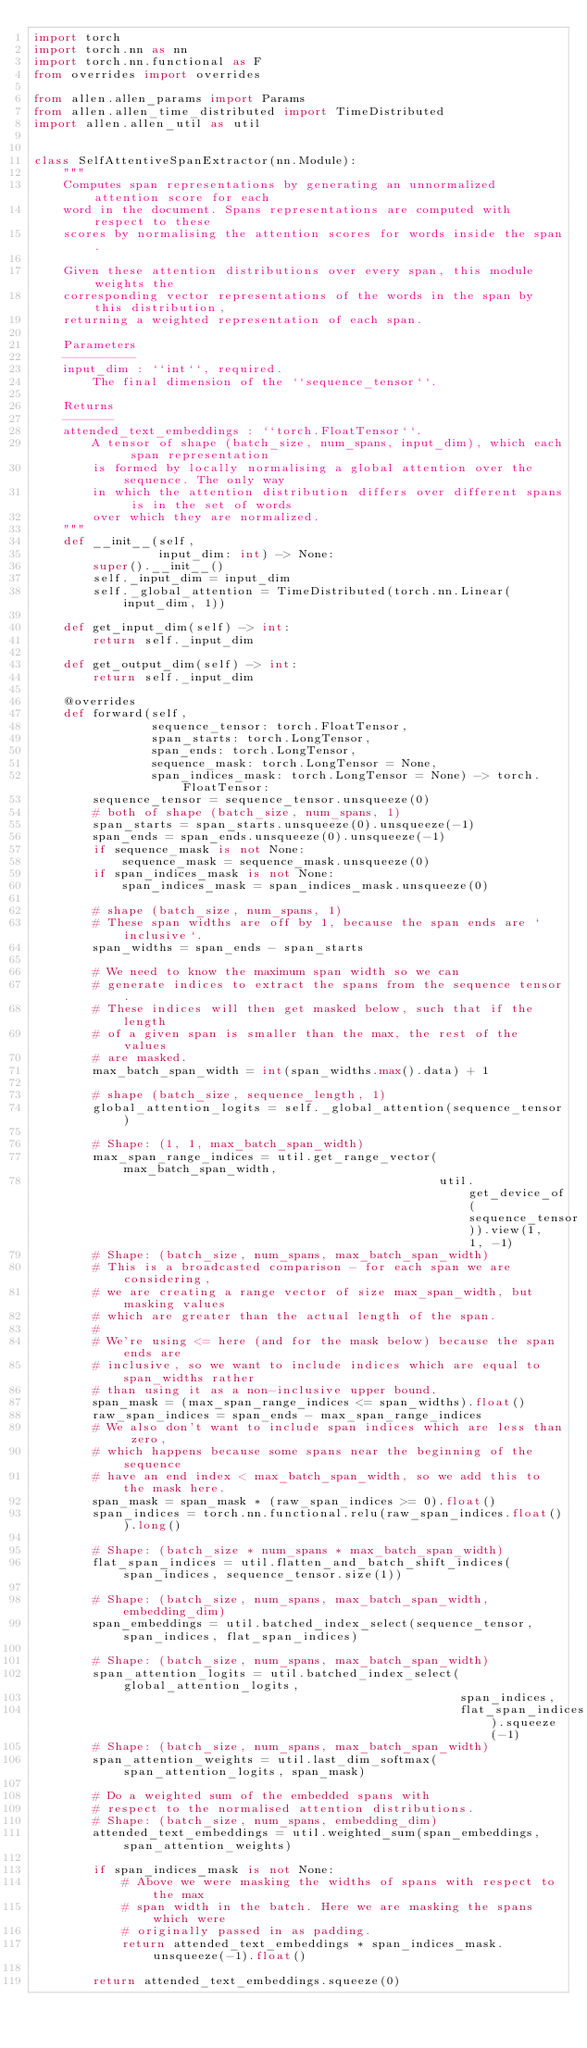Convert code to text. <code><loc_0><loc_0><loc_500><loc_500><_Python_>import torch
import torch.nn as nn
import torch.nn.functional as F
from overrides import overrides

from allen.allen_params import Params
from allen.allen_time_distributed import TimeDistributed
import allen.allen_util as util


class SelfAttentiveSpanExtractor(nn.Module):
    """
    Computes span representations by generating an unnormalized attention score for each
    word in the document. Spans representations are computed with respect to these
    scores by normalising the attention scores for words inside the span.

    Given these attention distributions over every span, this module weights the
    corresponding vector representations of the words in the span by this distribution,
    returning a weighted representation of each span.

    Parameters
    ----------
    input_dim : ``int``, required.
        The final dimension of the ``sequence_tensor``.

    Returns
    -------
    attended_text_embeddings : ``torch.FloatTensor``.
        A tensor of shape (batch_size, num_spans, input_dim), which each span representation
        is formed by locally normalising a global attention over the sequence. The only way
        in which the attention distribution differs over different spans is in the set of words
        over which they are normalized.
    """
    def __init__(self,
                 input_dim: int) -> None:
        super().__init__()
        self._input_dim = input_dim
        self._global_attention = TimeDistributed(torch.nn.Linear(input_dim, 1))

    def get_input_dim(self) -> int:
        return self._input_dim

    def get_output_dim(self) -> int:
        return self._input_dim

    @overrides
    def forward(self,
                sequence_tensor: torch.FloatTensor,
                span_starts: torch.LongTensor,
                span_ends: torch.LongTensor,
                sequence_mask: torch.LongTensor = None,
                span_indices_mask: torch.LongTensor = None) -> torch.FloatTensor:
        sequence_tensor = sequence_tensor.unsqueeze(0)
        # both of shape (batch_size, num_spans, 1)
        span_starts = span_starts.unsqueeze(0).unsqueeze(-1)
        span_ends = span_ends.unsqueeze(0).unsqueeze(-1)
        if sequence_mask is not None:
            sequence_mask = sequence_mask.unsqueeze(0)
        if span_indices_mask is not None:
            span_indices_mask = span_indices_mask.unsqueeze(0)

        # shape (batch_size, num_spans, 1)
        # These span widths are off by 1, because the span ends are `inclusive`.
        span_widths = span_ends - span_starts

        # We need to know the maximum span width so we can
        # generate indices to extract the spans from the sequence tensor.
        # These indices will then get masked below, such that if the length
        # of a given span is smaller than the max, the rest of the values
        # are masked.
        max_batch_span_width = int(span_widths.max().data) + 1

        # shape (batch_size, sequence_length, 1)
        global_attention_logits = self._global_attention(sequence_tensor)

        # Shape: (1, 1, max_batch_span_width)
        max_span_range_indices = util.get_range_vector(max_batch_span_width,
                                                       util.get_device_of(sequence_tensor)).view(1, 1, -1)
        # Shape: (batch_size, num_spans, max_batch_span_width)
        # This is a broadcasted comparison - for each span we are considering,
        # we are creating a range vector of size max_span_width, but masking values
        # which are greater than the actual length of the span.
        #
        # We're using <= here (and for the mask below) because the span ends are
        # inclusive, so we want to include indices which are equal to span_widths rather
        # than using it as a non-inclusive upper bound.
        span_mask = (max_span_range_indices <= span_widths).float()
        raw_span_indices = span_ends - max_span_range_indices
        # We also don't want to include span indices which are less than zero,
        # which happens because some spans near the beginning of the sequence
        # have an end index < max_batch_span_width, so we add this to the mask here.
        span_mask = span_mask * (raw_span_indices >= 0).float()
        span_indices = torch.nn.functional.relu(raw_span_indices.float()).long()

        # Shape: (batch_size * num_spans * max_batch_span_width)
        flat_span_indices = util.flatten_and_batch_shift_indices(span_indices, sequence_tensor.size(1))

        # Shape: (batch_size, num_spans, max_batch_span_width, embedding_dim)
        span_embeddings = util.batched_index_select(sequence_tensor, span_indices, flat_span_indices)

        # Shape: (batch_size, num_spans, max_batch_span_width)
        span_attention_logits = util.batched_index_select(global_attention_logits,
                                                          span_indices,
                                                          flat_span_indices).squeeze(-1)
        # Shape: (batch_size, num_spans, max_batch_span_width)
        span_attention_weights = util.last_dim_softmax(span_attention_logits, span_mask)

        # Do a weighted sum of the embedded spans with
        # respect to the normalised attention distributions.
        # Shape: (batch_size, num_spans, embedding_dim)
        attended_text_embeddings = util.weighted_sum(span_embeddings, span_attention_weights)

        if span_indices_mask is not None:
            # Above we were masking the widths of spans with respect to the max
            # span width in the batch. Here we are masking the spans which were
            # originally passed in as padding.
            return attended_text_embeddings * span_indices_mask.unsqueeze(-1).float()

        return attended_text_embeddings.squeeze(0)
</code> 